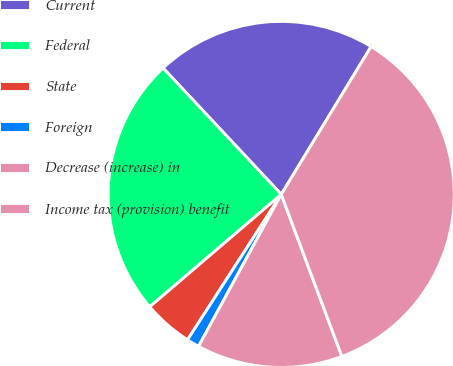Convert chart. <chart><loc_0><loc_0><loc_500><loc_500><pie_chart><fcel>Current<fcel>Federal<fcel>State<fcel>Foreign<fcel>Decrease (increase) in<fcel>Income tax (provision) benefit<nl><fcel>20.66%<fcel>24.29%<fcel>4.63%<fcel>1.18%<fcel>13.63%<fcel>35.61%<nl></chart> 